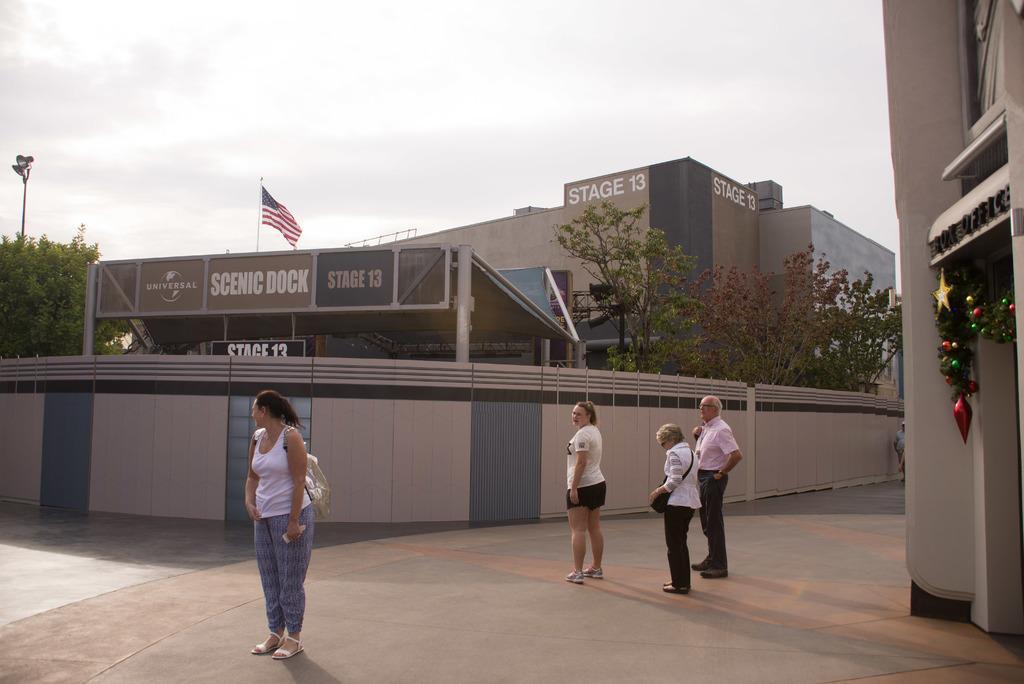In one or two sentences, can you explain what this image depicts? In the picture I can see people standing on the ground. In the background I can see buildings, trees, a flag, fence wall, a flag and some other objects. In the background I can see the sky. 